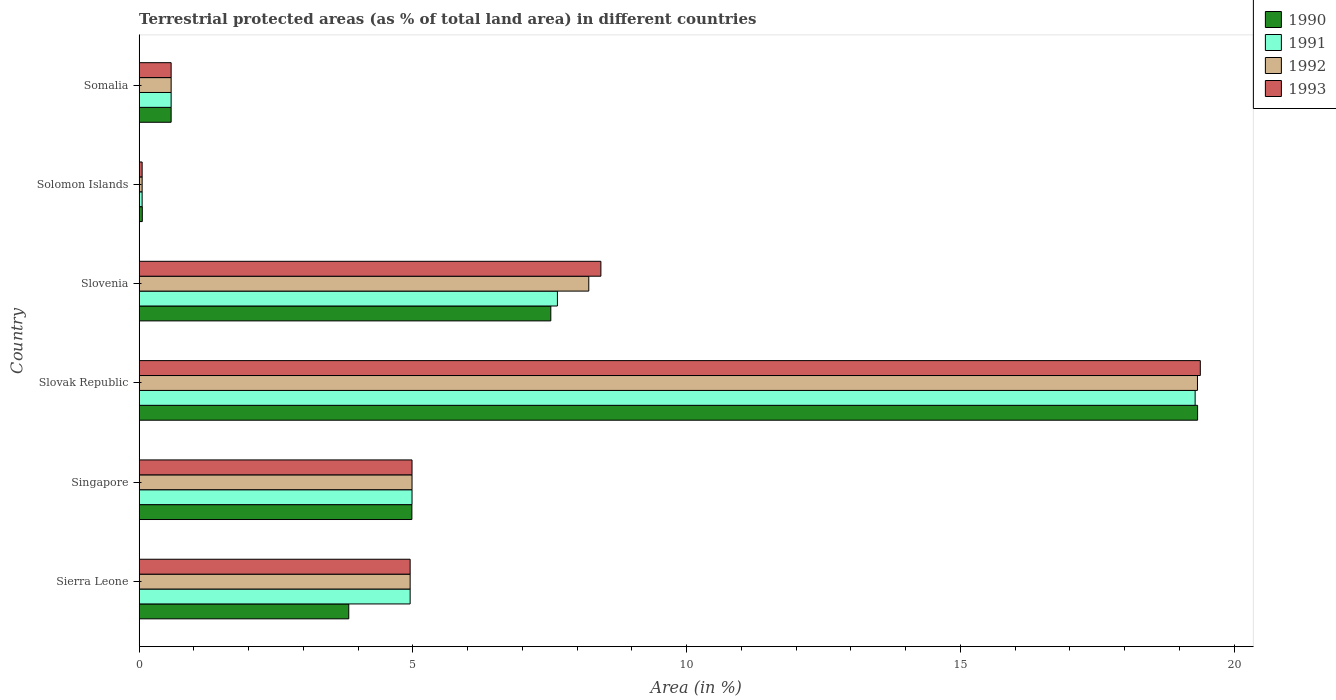How many groups of bars are there?
Your response must be concise. 6. What is the label of the 2nd group of bars from the top?
Offer a very short reply. Solomon Islands. What is the percentage of terrestrial protected land in 1990 in Somalia?
Provide a short and direct response. 0.58. Across all countries, what is the maximum percentage of terrestrial protected land in 1992?
Provide a short and direct response. 19.33. Across all countries, what is the minimum percentage of terrestrial protected land in 1992?
Provide a succinct answer. 0.05. In which country was the percentage of terrestrial protected land in 1990 maximum?
Your response must be concise. Slovak Republic. In which country was the percentage of terrestrial protected land in 1992 minimum?
Offer a very short reply. Solomon Islands. What is the total percentage of terrestrial protected land in 1991 in the graph?
Ensure brevity in your answer.  37.5. What is the difference between the percentage of terrestrial protected land in 1992 in Slovenia and that in Solomon Islands?
Your response must be concise. 8.16. What is the difference between the percentage of terrestrial protected land in 1991 in Somalia and the percentage of terrestrial protected land in 1992 in Slovak Republic?
Make the answer very short. -18.75. What is the average percentage of terrestrial protected land in 1993 per country?
Provide a short and direct response. 6.4. What is the difference between the percentage of terrestrial protected land in 1991 and percentage of terrestrial protected land in 1993 in Solomon Islands?
Your answer should be very brief. 0. What is the ratio of the percentage of terrestrial protected land in 1993 in Slovak Republic to that in Somalia?
Your response must be concise. 33.19. What is the difference between the highest and the second highest percentage of terrestrial protected land in 1993?
Provide a succinct answer. 10.95. What is the difference between the highest and the lowest percentage of terrestrial protected land in 1992?
Provide a succinct answer. 19.28. In how many countries, is the percentage of terrestrial protected land in 1990 greater than the average percentage of terrestrial protected land in 1990 taken over all countries?
Your response must be concise. 2. Is the sum of the percentage of terrestrial protected land in 1991 in Slovenia and Somalia greater than the maximum percentage of terrestrial protected land in 1990 across all countries?
Provide a short and direct response. No. Is it the case that in every country, the sum of the percentage of terrestrial protected land in 1992 and percentage of terrestrial protected land in 1993 is greater than the percentage of terrestrial protected land in 1990?
Ensure brevity in your answer.  Yes. Does the graph contain any zero values?
Your answer should be compact. No. Where does the legend appear in the graph?
Offer a very short reply. Top right. What is the title of the graph?
Offer a very short reply. Terrestrial protected areas (as % of total land area) in different countries. What is the label or title of the X-axis?
Your answer should be compact. Area (in %). What is the label or title of the Y-axis?
Your answer should be compact. Country. What is the Area (in %) in 1990 in Sierra Leone?
Provide a succinct answer. 3.83. What is the Area (in %) of 1991 in Sierra Leone?
Give a very brief answer. 4.95. What is the Area (in %) in 1992 in Sierra Leone?
Your response must be concise. 4.95. What is the Area (in %) of 1993 in Sierra Leone?
Your answer should be very brief. 4.95. What is the Area (in %) of 1990 in Singapore?
Offer a very short reply. 4.98. What is the Area (in %) in 1991 in Singapore?
Give a very brief answer. 4.98. What is the Area (in %) in 1992 in Singapore?
Your response must be concise. 4.98. What is the Area (in %) of 1993 in Singapore?
Ensure brevity in your answer.  4.98. What is the Area (in %) in 1990 in Slovak Republic?
Your answer should be very brief. 19.33. What is the Area (in %) in 1991 in Slovak Republic?
Ensure brevity in your answer.  19.29. What is the Area (in %) in 1992 in Slovak Republic?
Provide a short and direct response. 19.33. What is the Area (in %) of 1993 in Slovak Republic?
Offer a very short reply. 19.38. What is the Area (in %) of 1990 in Slovenia?
Provide a short and direct response. 7.52. What is the Area (in %) of 1991 in Slovenia?
Your answer should be very brief. 7.64. What is the Area (in %) in 1992 in Slovenia?
Provide a succinct answer. 8.21. What is the Area (in %) in 1993 in Slovenia?
Provide a succinct answer. 8.43. What is the Area (in %) in 1990 in Solomon Islands?
Offer a terse response. 0.06. What is the Area (in %) in 1991 in Solomon Islands?
Your answer should be very brief. 0.05. What is the Area (in %) in 1992 in Solomon Islands?
Your answer should be very brief. 0.05. What is the Area (in %) in 1993 in Solomon Islands?
Your answer should be very brief. 0.05. What is the Area (in %) of 1990 in Somalia?
Your answer should be very brief. 0.58. What is the Area (in %) in 1991 in Somalia?
Your answer should be compact. 0.58. What is the Area (in %) of 1992 in Somalia?
Your answer should be compact. 0.58. What is the Area (in %) in 1993 in Somalia?
Provide a succinct answer. 0.58. Across all countries, what is the maximum Area (in %) in 1990?
Ensure brevity in your answer.  19.33. Across all countries, what is the maximum Area (in %) in 1991?
Keep it short and to the point. 19.29. Across all countries, what is the maximum Area (in %) of 1992?
Keep it short and to the point. 19.33. Across all countries, what is the maximum Area (in %) in 1993?
Give a very brief answer. 19.38. Across all countries, what is the minimum Area (in %) of 1990?
Keep it short and to the point. 0.06. Across all countries, what is the minimum Area (in %) of 1991?
Your response must be concise. 0.05. Across all countries, what is the minimum Area (in %) in 1992?
Make the answer very short. 0.05. Across all countries, what is the minimum Area (in %) in 1993?
Give a very brief answer. 0.05. What is the total Area (in %) of 1990 in the graph?
Provide a short and direct response. 36.3. What is the total Area (in %) of 1991 in the graph?
Your answer should be very brief. 37.5. What is the total Area (in %) of 1992 in the graph?
Keep it short and to the point. 38.11. What is the total Area (in %) in 1993 in the graph?
Your response must be concise. 38.39. What is the difference between the Area (in %) of 1990 in Sierra Leone and that in Singapore?
Your answer should be compact. -1.15. What is the difference between the Area (in %) of 1991 in Sierra Leone and that in Singapore?
Give a very brief answer. -0.03. What is the difference between the Area (in %) of 1992 in Sierra Leone and that in Singapore?
Provide a succinct answer. -0.03. What is the difference between the Area (in %) in 1993 in Sierra Leone and that in Singapore?
Offer a very short reply. -0.03. What is the difference between the Area (in %) of 1990 in Sierra Leone and that in Slovak Republic?
Provide a succinct answer. -15.5. What is the difference between the Area (in %) of 1991 in Sierra Leone and that in Slovak Republic?
Ensure brevity in your answer.  -14.34. What is the difference between the Area (in %) in 1992 in Sierra Leone and that in Slovak Republic?
Provide a short and direct response. -14.38. What is the difference between the Area (in %) in 1993 in Sierra Leone and that in Slovak Republic?
Ensure brevity in your answer.  -14.43. What is the difference between the Area (in %) of 1990 in Sierra Leone and that in Slovenia?
Your response must be concise. -3.69. What is the difference between the Area (in %) in 1991 in Sierra Leone and that in Slovenia?
Provide a short and direct response. -2.69. What is the difference between the Area (in %) of 1992 in Sierra Leone and that in Slovenia?
Provide a succinct answer. -3.26. What is the difference between the Area (in %) in 1993 in Sierra Leone and that in Slovenia?
Your response must be concise. -3.48. What is the difference between the Area (in %) of 1990 in Sierra Leone and that in Solomon Islands?
Give a very brief answer. 3.77. What is the difference between the Area (in %) of 1991 in Sierra Leone and that in Solomon Islands?
Give a very brief answer. 4.89. What is the difference between the Area (in %) in 1992 in Sierra Leone and that in Solomon Islands?
Give a very brief answer. 4.89. What is the difference between the Area (in %) of 1993 in Sierra Leone and that in Solomon Islands?
Give a very brief answer. 4.89. What is the difference between the Area (in %) of 1990 in Sierra Leone and that in Somalia?
Your response must be concise. 3.24. What is the difference between the Area (in %) of 1991 in Sierra Leone and that in Somalia?
Ensure brevity in your answer.  4.37. What is the difference between the Area (in %) in 1992 in Sierra Leone and that in Somalia?
Offer a very short reply. 4.37. What is the difference between the Area (in %) in 1993 in Sierra Leone and that in Somalia?
Offer a very short reply. 4.37. What is the difference between the Area (in %) in 1990 in Singapore and that in Slovak Republic?
Your answer should be compact. -14.35. What is the difference between the Area (in %) of 1991 in Singapore and that in Slovak Republic?
Give a very brief answer. -14.3. What is the difference between the Area (in %) of 1992 in Singapore and that in Slovak Republic?
Keep it short and to the point. -14.35. What is the difference between the Area (in %) of 1993 in Singapore and that in Slovak Republic?
Your response must be concise. -14.4. What is the difference between the Area (in %) in 1990 in Singapore and that in Slovenia?
Offer a very short reply. -2.54. What is the difference between the Area (in %) of 1991 in Singapore and that in Slovenia?
Your response must be concise. -2.66. What is the difference between the Area (in %) in 1992 in Singapore and that in Slovenia?
Ensure brevity in your answer.  -3.23. What is the difference between the Area (in %) of 1993 in Singapore and that in Slovenia?
Provide a short and direct response. -3.45. What is the difference between the Area (in %) of 1990 in Singapore and that in Solomon Islands?
Provide a succinct answer. 4.92. What is the difference between the Area (in %) of 1991 in Singapore and that in Solomon Islands?
Provide a succinct answer. 4.93. What is the difference between the Area (in %) in 1992 in Singapore and that in Solomon Islands?
Your answer should be very brief. 4.93. What is the difference between the Area (in %) of 1993 in Singapore and that in Solomon Islands?
Your response must be concise. 4.93. What is the difference between the Area (in %) of 1990 in Singapore and that in Somalia?
Offer a very short reply. 4.4. What is the difference between the Area (in %) of 1991 in Singapore and that in Somalia?
Your answer should be compact. 4.4. What is the difference between the Area (in %) of 1993 in Singapore and that in Somalia?
Offer a terse response. 4.4. What is the difference between the Area (in %) of 1990 in Slovak Republic and that in Slovenia?
Give a very brief answer. 11.81. What is the difference between the Area (in %) of 1991 in Slovak Republic and that in Slovenia?
Your answer should be very brief. 11.65. What is the difference between the Area (in %) of 1992 in Slovak Republic and that in Slovenia?
Provide a short and direct response. 11.12. What is the difference between the Area (in %) of 1993 in Slovak Republic and that in Slovenia?
Provide a short and direct response. 10.95. What is the difference between the Area (in %) in 1990 in Slovak Republic and that in Solomon Islands?
Provide a succinct answer. 19.27. What is the difference between the Area (in %) of 1991 in Slovak Republic and that in Solomon Islands?
Give a very brief answer. 19.23. What is the difference between the Area (in %) in 1992 in Slovak Republic and that in Solomon Islands?
Your response must be concise. 19.28. What is the difference between the Area (in %) of 1993 in Slovak Republic and that in Solomon Islands?
Provide a short and direct response. 19.33. What is the difference between the Area (in %) of 1990 in Slovak Republic and that in Somalia?
Provide a short and direct response. 18.75. What is the difference between the Area (in %) in 1991 in Slovak Republic and that in Somalia?
Make the answer very short. 18.7. What is the difference between the Area (in %) of 1992 in Slovak Republic and that in Somalia?
Keep it short and to the point. 18.75. What is the difference between the Area (in %) in 1993 in Slovak Republic and that in Somalia?
Ensure brevity in your answer.  18.8. What is the difference between the Area (in %) of 1990 in Slovenia and that in Solomon Islands?
Provide a succinct answer. 7.46. What is the difference between the Area (in %) in 1991 in Slovenia and that in Solomon Islands?
Give a very brief answer. 7.58. What is the difference between the Area (in %) in 1992 in Slovenia and that in Solomon Islands?
Keep it short and to the point. 8.16. What is the difference between the Area (in %) in 1993 in Slovenia and that in Solomon Islands?
Ensure brevity in your answer.  8.38. What is the difference between the Area (in %) of 1990 in Slovenia and that in Somalia?
Keep it short and to the point. 6.93. What is the difference between the Area (in %) in 1991 in Slovenia and that in Somalia?
Make the answer very short. 7.06. What is the difference between the Area (in %) of 1992 in Slovenia and that in Somalia?
Your answer should be compact. 7.63. What is the difference between the Area (in %) in 1993 in Slovenia and that in Somalia?
Offer a terse response. 7.85. What is the difference between the Area (in %) in 1990 in Solomon Islands and that in Somalia?
Ensure brevity in your answer.  -0.53. What is the difference between the Area (in %) of 1991 in Solomon Islands and that in Somalia?
Offer a very short reply. -0.53. What is the difference between the Area (in %) of 1992 in Solomon Islands and that in Somalia?
Your answer should be very brief. -0.53. What is the difference between the Area (in %) in 1993 in Solomon Islands and that in Somalia?
Your answer should be very brief. -0.53. What is the difference between the Area (in %) in 1990 in Sierra Leone and the Area (in %) in 1991 in Singapore?
Give a very brief answer. -1.16. What is the difference between the Area (in %) of 1990 in Sierra Leone and the Area (in %) of 1992 in Singapore?
Offer a terse response. -1.16. What is the difference between the Area (in %) of 1990 in Sierra Leone and the Area (in %) of 1993 in Singapore?
Give a very brief answer. -1.16. What is the difference between the Area (in %) in 1991 in Sierra Leone and the Area (in %) in 1992 in Singapore?
Offer a very short reply. -0.03. What is the difference between the Area (in %) of 1991 in Sierra Leone and the Area (in %) of 1993 in Singapore?
Keep it short and to the point. -0.03. What is the difference between the Area (in %) of 1992 in Sierra Leone and the Area (in %) of 1993 in Singapore?
Keep it short and to the point. -0.03. What is the difference between the Area (in %) of 1990 in Sierra Leone and the Area (in %) of 1991 in Slovak Republic?
Your answer should be compact. -15.46. What is the difference between the Area (in %) of 1990 in Sierra Leone and the Area (in %) of 1992 in Slovak Republic?
Make the answer very short. -15.5. What is the difference between the Area (in %) in 1990 in Sierra Leone and the Area (in %) in 1993 in Slovak Republic?
Ensure brevity in your answer.  -15.55. What is the difference between the Area (in %) in 1991 in Sierra Leone and the Area (in %) in 1992 in Slovak Republic?
Offer a very short reply. -14.38. What is the difference between the Area (in %) of 1991 in Sierra Leone and the Area (in %) of 1993 in Slovak Republic?
Make the answer very short. -14.43. What is the difference between the Area (in %) of 1992 in Sierra Leone and the Area (in %) of 1993 in Slovak Republic?
Your answer should be compact. -14.43. What is the difference between the Area (in %) in 1990 in Sierra Leone and the Area (in %) in 1991 in Slovenia?
Offer a terse response. -3.81. What is the difference between the Area (in %) in 1990 in Sierra Leone and the Area (in %) in 1992 in Slovenia?
Your answer should be compact. -4.38. What is the difference between the Area (in %) of 1990 in Sierra Leone and the Area (in %) of 1993 in Slovenia?
Your answer should be compact. -4.61. What is the difference between the Area (in %) of 1991 in Sierra Leone and the Area (in %) of 1992 in Slovenia?
Give a very brief answer. -3.26. What is the difference between the Area (in %) in 1991 in Sierra Leone and the Area (in %) in 1993 in Slovenia?
Ensure brevity in your answer.  -3.48. What is the difference between the Area (in %) in 1992 in Sierra Leone and the Area (in %) in 1993 in Slovenia?
Your response must be concise. -3.48. What is the difference between the Area (in %) in 1990 in Sierra Leone and the Area (in %) in 1991 in Solomon Islands?
Give a very brief answer. 3.77. What is the difference between the Area (in %) of 1990 in Sierra Leone and the Area (in %) of 1992 in Solomon Islands?
Ensure brevity in your answer.  3.77. What is the difference between the Area (in %) in 1990 in Sierra Leone and the Area (in %) in 1993 in Solomon Islands?
Keep it short and to the point. 3.77. What is the difference between the Area (in %) of 1991 in Sierra Leone and the Area (in %) of 1992 in Solomon Islands?
Your response must be concise. 4.89. What is the difference between the Area (in %) of 1991 in Sierra Leone and the Area (in %) of 1993 in Solomon Islands?
Give a very brief answer. 4.89. What is the difference between the Area (in %) in 1992 in Sierra Leone and the Area (in %) in 1993 in Solomon Islands?
Offer a very short reply. 4.89. What is the difference between the Area (in %) of 1990 in Sierra Leone and the Area (in %) of 1991 in Somalia?
Ensure brevity in your answer.  3.24. What is the difference between the Area (in %) in 1990 in Sierra Leone and the Area (in %) in 1992 in Somalia?
Keep it short and to the point. 3.24. What is the difference between the Area (in %) in 1990 in Sierra Leone and the Area (in %) in 1993 in Somalia?
Provide a succinct answer. 3.24. What is the difference between the Area (in %) of 1991 in Sierra Leone and the Area (in %) of 1992 in Somalia?
Ensure brevity in your answer.  4.37. What is the difference between the Area (in %) of 1991 in Sierra Leone and the Area (in %) of 1993 in Somalia?
Make the answer very short. 4.37. What is the difference between the Area (in %) of 1992 in Sierra Leone and the Area (in %) of 1993 in Somalia?
Your answer should be compact. 4.37. What is the difference between the Area (in %) of 1990 in Singapore and the Area (in %) of 1991 in Slovak Republic?
Ensure brevity in your answer.  -14.31. What is the difference between the Area (in %) of 1990 in Singapore and the Area (in %) of 1992 in Slovak Republic?
Provide a short and direct response. -14.35. What is the difference between the Area (in %) of 1990 in Singapore and the Area (in %) of 1993 in Slovak Republic?
Provide a succinct answer. -14.4. What is the difference between the Area (in %) in 1991 in Singapore and the Area (in %) in 1992 in Slovak Republic?
Keep it short and to the point. -14.35. What is the difference between the Area (in %) in 1991 in Singapore and the Area (in %) in 1993 in Slovak Republic?
Your answer should be compact. -14.4. What is the difference between the Area (in %) in 1992 in Singapore and the Area (in %) in 1993 in Slovak Republic?
Your response must be concise. -14.4. What is the difference between the Area (in %) in 1990 in Singapore and the Area (in %) in 1991 in Slovenia?
Give a very brief answer. -2.66. What is the difference between the Area (in %) in 1990 in Singapore and the Area (in %) in 1992 in Slovenia?
Provide a succinct answer. -3.23. What is the difference between the Area (in %) of 1990 in Singapore and the Area (in %) of 1993 in Slovenia?
Your response must be concise. -3.45. What is the difference between the Area (in %) of 1991 in Singapore and the Area (in %) of 1992 in Slovenia?
Your answer should be compact. -3.23. What is the difference between the Area (in %) in 1991 in Singapore and the Area (in %) in 1993 in Slovenia?
Ensure brevity in your answer.  -3.45. What is the difference between the Area (in %) of 1992 in Singapore and the Area (in %) of 1993 in Slovenia?
Offer a very short reply. -3.45. What is the difference between the Area (in %) of 1990 in Singapore and the Area (in %) of 1991 in Solomon Islands?
Your response must be concise. 4.93. What is the difference between the Area (in %) of 1990 in Singapore and the Area (in %) of 1992 in Solomon Islands?
Give a very brief answer. 4.93. What is the difference between the Area (in %) in 1990 in Singapore and the Area (in %) in 1993 in Solomon Islands?
Make the answer very short. 4.93. What is the difference between the Area (in %) in 1991 in Singapore and the Area (in %) in 1992 in Solomon Islands?
Your answer should be very brief. 4.93. What is the difference between the Area (in %) in 1991 in Singapore and the Area (in %) in 1993 in Solomon Islands?
Ensure brevity in your answer.  4.93. What is the difference between the Area (in %) of 1992 in Singapore and the Area (in %) of 1993 in Solomon Islands?
Keep it short and to the point. 4.93. What is the difference between the Area (in %) in 1990 in Singapore and the Area (in %) in 1991 in Somalia?
Make the answer very short. 4.4. What is the difference between the Area (in %) in 1990 in Singapore and the Area (in %) in 1992 in Somalia?
Your response must be concise. 4.4. What is the difference between the Area (in %) in 1990 in Singapore and the Area (in %) in 1993 in Somalia?
Make the answer very short. 4.4. What is the difference between the Area (in %) in 1991 in Singapore and the Area (in %) in 1992 in Somalia?
Your answer should be compact. 4.4. What is the difference between the Area (in %) in 1992 in Singapore and the Area (in %) in 1993 in Somalia?
Offer a very short reply. 4.4. What is the difference between the Area (in %) in 1990 in Slovak Republic and the Area (in %) in 1991 in Slovenia?
Provide a short and direct response. 11.69. What is the difference between the Area (in %) of 1990 in Slovak Republic and the Area (in %) of 1992 in Slovenia?
Give a very brief answer. 11.12. What is the difference between the Area (in %) in 1990 in Slovak Republic and the Area (in %) in 1993 in Slovenia?
Offer a terse response. 10.9. What is the difference between the Area (in %) in 1991 in Slovak Republic and the Area (in %) in 1992 in Slovenia?
Offer a very short reply. 11.08. What is the difference between the Area (in %) in 1991 in Slovak Republic and the Area (in %) in 1993 in Slovenia?
Your answer should be compact. 10.85. What is the difference between the Area (in %) of 1992 in Slovak Republic and the Area (in %) of 1993 in Slovenia?
Keep it short and to the point. 10.9. What is the difference between the Area (in %) of 1990 in Slovak Republic and the Area (in %) of 1991 in Solomon Islands?
Provide a short and direct response. 19.28. What is the difference between the Area (in %) in 1990 in Slovak Republic and the Area (in %) in 1992 in Solomon Islands?
Your answer should be compact. 19.28. What is the difference between the Area (in %) of 1990 in Slovak Republic and the Area (in %) of 1993 in Solomon Islands?
Ensure brevity in your answer.  19.28. What is the difference between the Area (in %) of 1991 in Slovak Republic and the Area (in %) of 1992 in Solomon Islands?
Make the answer very short. 19.23. What is the difference between the Area (in %) of 1991 in Slovak Republic and the Area (in %) of 1993 in Solomon Islands?
Provide a short and direct response. 19.23. What is the difference between the Area (in %) of 1992 in Slovak Republic and the Area (in %) of 1993 in Solomon Islands?
Offer a terse response. 19.28. What is the difference between the Area (in %) of 1990 in Slovak Republic and the Area (in %) of 1991 in Somalia?
Your answer should be compact. 18.75. What is the difference between the Area (in %) in 1990 in Slovak Republic and the Area (in %) in 1992 in Somalia?
Ensure brevity in your answer.  18.75. What is the difference between the Area (in %) in 1990 in Slovak Republic and the Area (in %) in 1993 in Somalia?
Your answer should be compact. 18.75. What is the difference between the Area (in %) in 1991 in Slovak Republic and the Area (in %) in 1992 in Somalia?
Ensure brevity in your answer.  18.7. What is the difference between the Area (in %) of 1991 in Slovak Republic and the Area (in %) of 1993 in Somalia?
Your response must be concise. 18.7. What is the difference between the Area (in %) of 1992 in Slovak Republic and the Area (in %) of 1993 in Somalia?
Make the answer very short. 18.75. What is the difference between the Area (in %) in 1990 in Slovenia and the Area (in %) in 1991 in Solomon Islands?
Give a very brief answer. 7.46. What is the difference between the Area (in %) of 1990 in Slovenia and the Area (in %) of 1992 in Solomon Islands?
Keep it short and to the point. 7.46. What is the difference between the Area (in %) of 1990 in Slovenia and the Area (in %) of 1993 in Solomon Islands?
Keep it short and to the point. 7.46. What is the difference between the Area (in %) in 1991 in Slovenia and the Area (in %) in 1992 in Solomon Islands?
Provide a short and direct response. 7.58. What is the difference between the Area (in %) in 1991 in Slovenia and the Area (in %) in 1993 in Solomon Islands?
Give a very brief answer. 7.58. What is the difference between the Area (in %) of 1992 in Slovenia and the Area (in %) of 1993 in Solomon Islands?
Offer a very short reply. 8.16. What is the difference between the Area (in %) in 1990 in Slovenia and the Area (in %) in 1991 in Somalia?
Make the answer very short. 6.93. What is the difference between the Area (in %) in 1990 in Slovenia and the Area (in %) in 1992 in Somalia?
Your response must be concise. 6.93. What is the difference between the Area (in %) in 1990 in Slovenia and the Area (in %) in 1993 in Somalia?
Keep it short and to the point. 6.93. What is the difference between the Area (in %) in 1991 in Slovenia and the Area (in %) in 1992 in Somalia?
Offer a terse response. 7.06. What is the difference between the Area (in %) in 1991 in Slovenia and the Area (in %) in 1993 in Somalia?
Provide a succinct answer. 7.06. What is the difference between the Area (in %) in 1992 in Slovenia and the Area (in %) in 1993 in Somalia?
Keep it short and to the point. 7.63. What is the difference between the Area (in %) of 1990 in Solomon Islands and the Area (in %) of 1991 in Somalia?
Keep it short and to the point. -0.53. What is the difference between the Area (in %) of 1990 in Solomon Islands and the Area (in %) of 1992 in Somalia?
Give a very brief answer. -0.53. What is the difference between the Area (in %) of 1990 in Solomon Islands and the Area (in %) of 1993 in Somalia?
Your answer should be very brief. -0.53. What is the difference between the Area (in %) of 1991 in Solomon Islands and the Area (in %) of 1992 in Somalia?
Your response must be concise. -0.53. What is the difference between the Area (in %) in 1991 in Solomon Islands and the Area (in %) in 1993 in Somalia?
Keep it short and to the point. -0.53. What is the difference between the Area (in %) in 1992 in Solomon Islands and the Area (in %) in 1993 in Somalia?
Keep it short and to the point. -0.53. What is the average Area (in %) in 1990 per country?
Make the answer very short. 6.05. What is the average Area (in %) in 1991 per country?
Ensure brevity in your answer.  6.25. What is the average Area (in %) of 1992 per country?
Keep it short and to the point. 6.35. What is the average Area (in %) in 1993 per country?
Ensure brevity in your answer.  6.4. What is the difference between the Area (in %) of 1990 and Area (in %) of 1991 in Sierra Leone?
Offer a very short reply. -1.12. What is the difference between the Area (in %) of 1990 and Area (in %) of 1992 in Sierra Leone?
Make the answer very short. -1.12. What is the difference between the Area (in %) in 1990 and Area (in %) in 1993 in Sierra Leone?
Give a very brief answer. -1.12. What is the difference between the Area (in %) in 1991 and Area (in %) in 1992 in Sierra Leone?
Your answer should be very brief. 0. What is the difference between the Area (in %) in 1991 and Area (in %) in 1993 in Sierra Leone?
Provide a short and direct response. 0. What is the difference between the Area (in %) in 1992 and Area (in %) in 1993 in Sierra Leone?
Your answer should be very brief. 0. What is the difference between the Area (in %) in 1990 and Area (in %) in 1991 in Singapore?
Offer a terse response. -0. What is the difference between the Area (in %) in 1990 and Area (in %) in 1992 in Singapore?
Offer a very short reply. -0. What is the difference between the Area (in %) in 1990 and Area (in %) in 1993 in Singapore?
Provide a short and direct response. -0. What is the difference between the Area (in %) in 1990 and Area (in %) in 1991 in Slovak Republic?
Provide a short and direct response. 0.04. What is the difference between the Area (in %) in 1990 and Area (in %) in 1992 in Slovak Republic?
Your answer should be compact. 0. What is the difference between the Area (in %) of 1990 and Area (in %) of 1993 in Slovak Republic?
Offer a very short reply. -0.05. What is the difference between the Area (in %) of 1991 and Area (in %) of 1992 in Slovak Republic?
Your answer should be very brief. -0.04. What is the difference between the Area (in %) in 1991 and Area (in %) in 1993 in Slovak Republic?
Ensure brevity in your answer.  -0.09. What is the difference between the Area (in %) of 1992 and Area (in %) of 1993 in Slovak Republic?
Your answer should be compact. -0.05. What is the difference between the Area (in %) in 1990 and Area (in %) in 1991 in Slovenia?
Provide a short and direct response. -0.12. What is the difference between the Area (in %) of 1990 and Area (in %) of 1992 in Slovenia?
Your answer should be compact. -0.69. What is the difference between the Area (in %) of 1990 and Area (in %) of 1993 in Slovenia?
Provide a succinct answer. -0.91. What is the difference between the Area (in %) in 1991 and Area (in %) in 1992 in Slovenia?
Your answer should be very brief. -0.57. What is the difference between the Area (in %) in 1991 and Area (in %) in 1993 in Slovenia?
Your answer should be compact. -0.79. What is the difference between the Area (in %) in 1992 and Area (in %) in 1993 in Slovenia?
Ensure brevity in your answer.  -0.22. What is the difference between the Area (in %) in 1990 and Area (in %) in 1991 in Solomon Islands?
Make the answer very short. 0. What is the difference between the Area (in %) in 1990 and Area (in %) in 1992 in Solomon Islands?
Make the answer very short. 0. What is the difference between the Area (in %) in 1990 and Area (in %) in 1993 in Solomon Islands?
Keep it short and to the point. 0. What is the difference between the Area (in %) in 1992 and Area (in %) in 1993 in Solomon Islands?
Your answer should be very brief. 0. What is the difference between the Area (in %) in 1990 and Area (in %) in 1991 in Somalia?
Keep it short and to the point. 0. What is the difference between the Area (in %) of 1990 and Area (in %) of 1992 in Somalia?
Make the answer very short. 0. What is the difference between the Area (in %) in 1992 and Area (in %) in 1993 in Somalia?
Make the answer very short. 0. What is the ratio of the Area (in %) in 1990 in Sierra Leone to that in Singapore?
Ensure brevity in your answer.  0.77. What is the ratio of the Area (in %) of 1991 in Sierra Leone to that in Singapore?
Offer a very short reply. 0.99. What is the ratio of the Area (in %) in 1992 in Sierra Leone to that in Singapore?
Your answer should be compact. 0.99. What is the ratio of the Area (in %) in 1990 in Sierra Leone to that in Slovak Republic?
Your answer should be compact. 0.2. What is the ratio of the Area (in %) in 1991 in Sierra Leone to that in Slovak Republic?
Keep it short and to the point. 0.26. What is the ratio of the Area (in %) of 1992 in Sierra Leone to that in Slovak Republic?
Your answer should be very brief. 0.26. What is the ratio of the Area (in %) in 1993 in Sierra Leone to that in Slovak Republic?
Keep it short and to the point. 0.26. What is the ratio of the Area (in %) of 1990 in Sierra Leone to that in Slovenia?
Make the answer very short. 0.51. What is the ratio of the Area (in %) in 1991 in Sierra Leone to that in Slovenia?
Offer a terse response. 0.65. What is the ratio of the Area (in %) in 1992 in Sierra Leone to that in Slovenia?
Your answer should be compact. 0.6. What is the ratio of the Area (in %) of 1993 in Sierra Leone to that in Slovenia?
Offer a very short reply. 0.59. What is the ratio of the Area (in %) in 1990 in Sierra Leone to that in Solomon Islands?
Keep it short and to the point. 66.59. What is the ratio of the Area (in %) of 1991 in Sierra Leone to that in Solomon Islands?
Your answer should be very brief. 90.87. What is the ratio of the Area (in %) of 1992 in Sierra Leone to that in Solomon Islands?
Offer a very short reply. 90.87. What is the ratio of the Area (in %) of 1993 in Sierra Leone to that in Solomon Islands?
Provide a short and direct response. 90.87. What is the ratio of the Area (in %) in 1990 in Sierra Leone to that in Somalia?
Make the answer very short. 6.56. What is the ratio of the Area (in %) of 1991 in Sierra Leone to that in Somalia?
Offer a terse response. 8.48. What is the ratio of the Area (in %) of 1992 in Sierra Leone to that in Somalia?
Provide a short and direct response. 8.48. What is the ratio of the Area (in %) in 1993 in Sierra Leone to that in Somalia?
Provide a short and direct response. 8.48. What is the ratio of the Area (in %) in 1990 in Singapore to that in Slovak Republic?
Your answer should be very brief. 0.26. What is the ratio of the Area (in %) in 1991 in Singapore to that in Slovak Republic?
Provide a succinct answer. 0.26. What is the ratio of the Area (in %) of 1992 in Singapore to that in Slovak Republic?
Provide a succinct answer. 0.26. What is the ratio of the Area (in %) in 1993 in Singapore to that in Slovak Republic?
Provide a succinct answer. 0.26. What is the ratio of the Area (in %) of 1990 in Singapore to that in Slovenia?
Keep it short and to the point. 0.66. What is the ratio of the Area (in %) of 1991 in Singapore to that in Slovenia?
Your answer should be compact. 0.65. What is the ratio of the Area (in %) in 1992 in Singapore to that in Slovenia?
Make the answer very short. 0.61. What is the ratio of the Area (in %) of 1993 in Singapore to that in Slovenia?
Make the answer very short. 0.59. What is the ratio of the Area (in %) in 1990 in Singapore to that in Solomon Islands?
Your answer should be compact. 86.65. What is the ratio of the Area (in %) of 1991 in Singapore to that in Solomon Islands?
Give a very brief answer. 91.5. What is the ratio of the Area (in %) of 1992 in Singapore to that in Solomon Islands?
Provide a short and direct response. 91.5. What is the ratio of the Area (in %) in 1993 in Singapore to that in Solomon Islands?
Give a very brief answer. 91.5. What is the ratio of the Area (in %) in 1990 in Singapore to that in Somalia?
Provide a short and direct response. 8.53. What is the ratio of the Area (in %) in 1991 in Singapore to that in Somalia?
Ensure brevity in your answer.  8.53. What is the ratio of the Area (in %) of 1992 in Singapore to that in Somalia?
Offer a very short reply. 8.53. What is the ratio of the Area (in %) in 1993 in Singapore to that in Somalia?
Provide a short and direct response. 8.53. What is the ratio of the Area (in %) in 1990 in Slovak Republic to that in Slovenia?
Offer a very short reply. 2.57. What is the ratio of the Area (in %) of 1991 in Slovak Republic to that in Slovenia?
Make the answer very short. 2.52. What is the ratio of the Area (in %) of 1992 in Slovak Republic to that in Slovenia?
Your answer should be very brief. 2.35. What is the ratio of the Area (in %) of 1993 in Slovak Republic to that in Slovenia?
Keep it short and to the point. 2.3. What is the ratio of the Area (in %) of 1990 in Slovak Republic to that in Solomon Islands?
Provide a succinct answer. 336.26. What is the ratio of the Area (in %) in 1991 in Slovak Republic to that in Solomon Islands?
Make the answer very short. 354.1. What is the ratio of the Area (in %) of 1992 in Slovak Republic to that in Solomon Islands?
Provide a succinct answer. 354.88. What is the ratio of the Area (in %) of 1993 in Slovak Republic to that in Solomon Islands?
Offer a very short reply. 355.84. What is the ratio of the Area (in %) of 1990 in Slovak Republic to that in Somalia?
Offer a terse response. 33.1. What is the ratio of the Area (in %) of 1991 in Slovak Republic to that in Somalia?
Provide a succinct answer. 33.03. What is the ratio of the Area (in %) in 1992 in Slovak Republic to that in Somalia?
Provide a short and direct response. 33.1. What is the ratio of the Area (in %) of 1993 in Slovak Republic to that in Somalia?
Offer a terse response. 33.19. What is the ratio of the Area (in %) in 1990 in Slovenia to that in Solomon Islands?
Make the answer very short. 130.78. What is the ratio of the Area (in %) of 1991 in Slovenia to that in Solomon Islands?
Your response must be concise. 140.25. What is the ratio of the Area (in %) in 1992 in Slovenia to that in Solomon Islands?
Your answer should be compact. 150.77. What is the ratio of the Area (in %) of 1993 in Slovenia to that in Solomon Islands?
Your response must be concise. 154.83. What is the ratio of the Area (in %) in 1990 in Slovenia to that in Somalia?
Your response must be concise. 12.87. What is the ratio of the Area (in %) of 1991 in Slovenia to that in Somalia?
Provide a succinct answer. 13.08. What is the ratio of the Area (in %) in 1992 in Slovenia to that in Somalia?
Your answer should be compact. 14.06. What is the ratio of the Area (in %) of 1993 in Slovenia to that in Somalia?
Offer a very short reply. 14.44. What is the ratio of the Area (in %) in 1990 in Solomon Islands to that in Somalia?
Your response must be concise. 0.1. What is the ratio of the Area (in %) in 1991 in Solomon Islands to that in Somalia?
Ensure brevity in your answer.  0.09. What is the ratio of the Area (in %) of 1992 in Solomon Islands to that in Somalia?
Offer a very short reply. 0.09. What is the ratio of the Area (in %) in 1993 in Solomon Islands to that in Somalia?
Ensure brevity in your answer.  0.09. What is the difference between the highest and the second highest Area (in %) in 1990?
Ensure brevity in your answer.  11.81. What is the difference between the highest and the second highest Area (in %) in 1991?
Make the answer very short. 11.65. What is the difference between the highest and the second highest Area (in %) of 1992?
Your answer should be compact. 11.12. What is the difference between the highest and the second highest Area (in %) of 1993?
Offer a very short reply. 10.95. What is the difference between the highest and the lowest Area (in %) in 1990?
Your answer should be compact. 19.27. What is the difference between the highest and the lowest Area (in %) of 1991?
Offer a terse response. 19.23. What is the difference between the highest and the lowest Area (in %) in 1992?
Provide a succinct answer. 19.28. What is the difference between the highest and the lowest Area (in %) in 1993?
Provide a succinct answer. 19.33. 